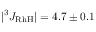<formula> <loc_0><loc_0><loc_500><loc_500>| ^ { 3 } J _ { R h H } | = 4 . 7 \pm 0 . 1</formula> 